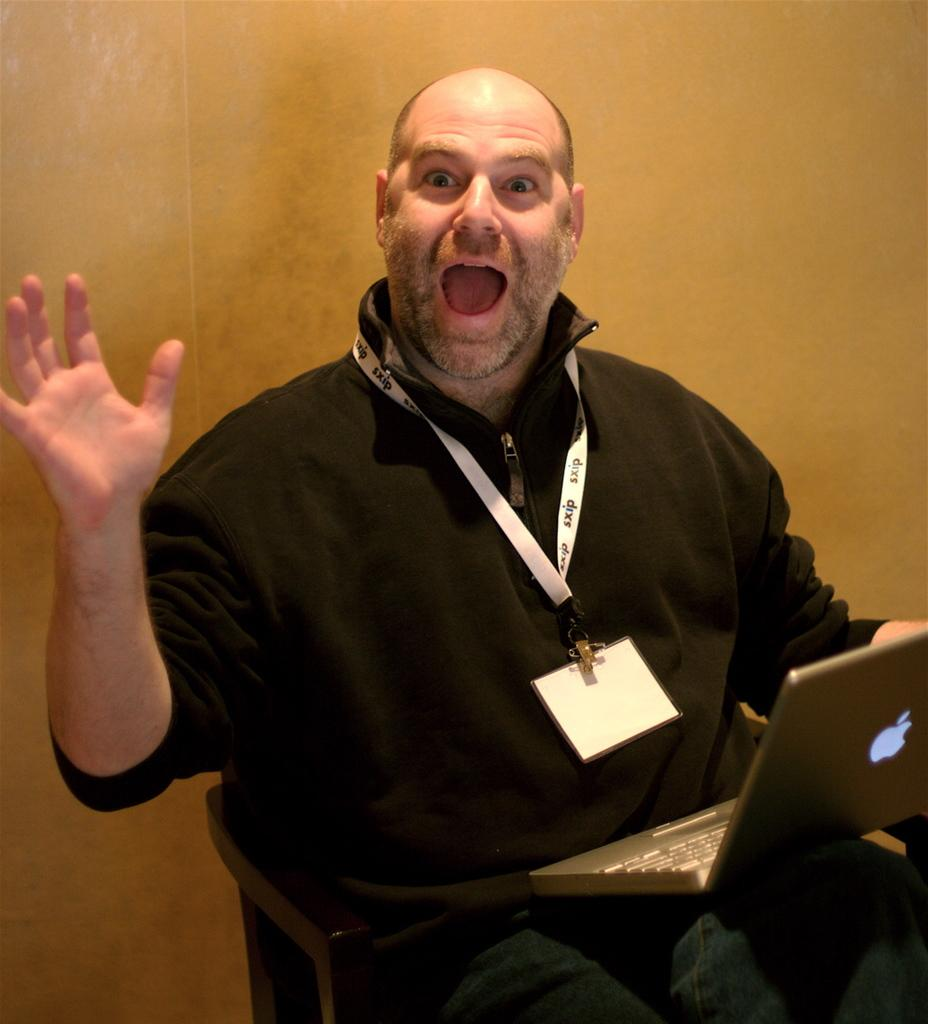Who is the main subject in the image? There is a person in the center of the image. What is the person doing in the image? The person is sitting on a chair and screaming. What object is the person holding in the image? The person is holding a laptop. What can be seen in the background of the image? There is a wall in the background of the image. What type of flowers can be seen in the advertisement in the image? There is no advertisement or flowers present in the image; it features a person sitting on a chair, screaming, and holding a laptop. 